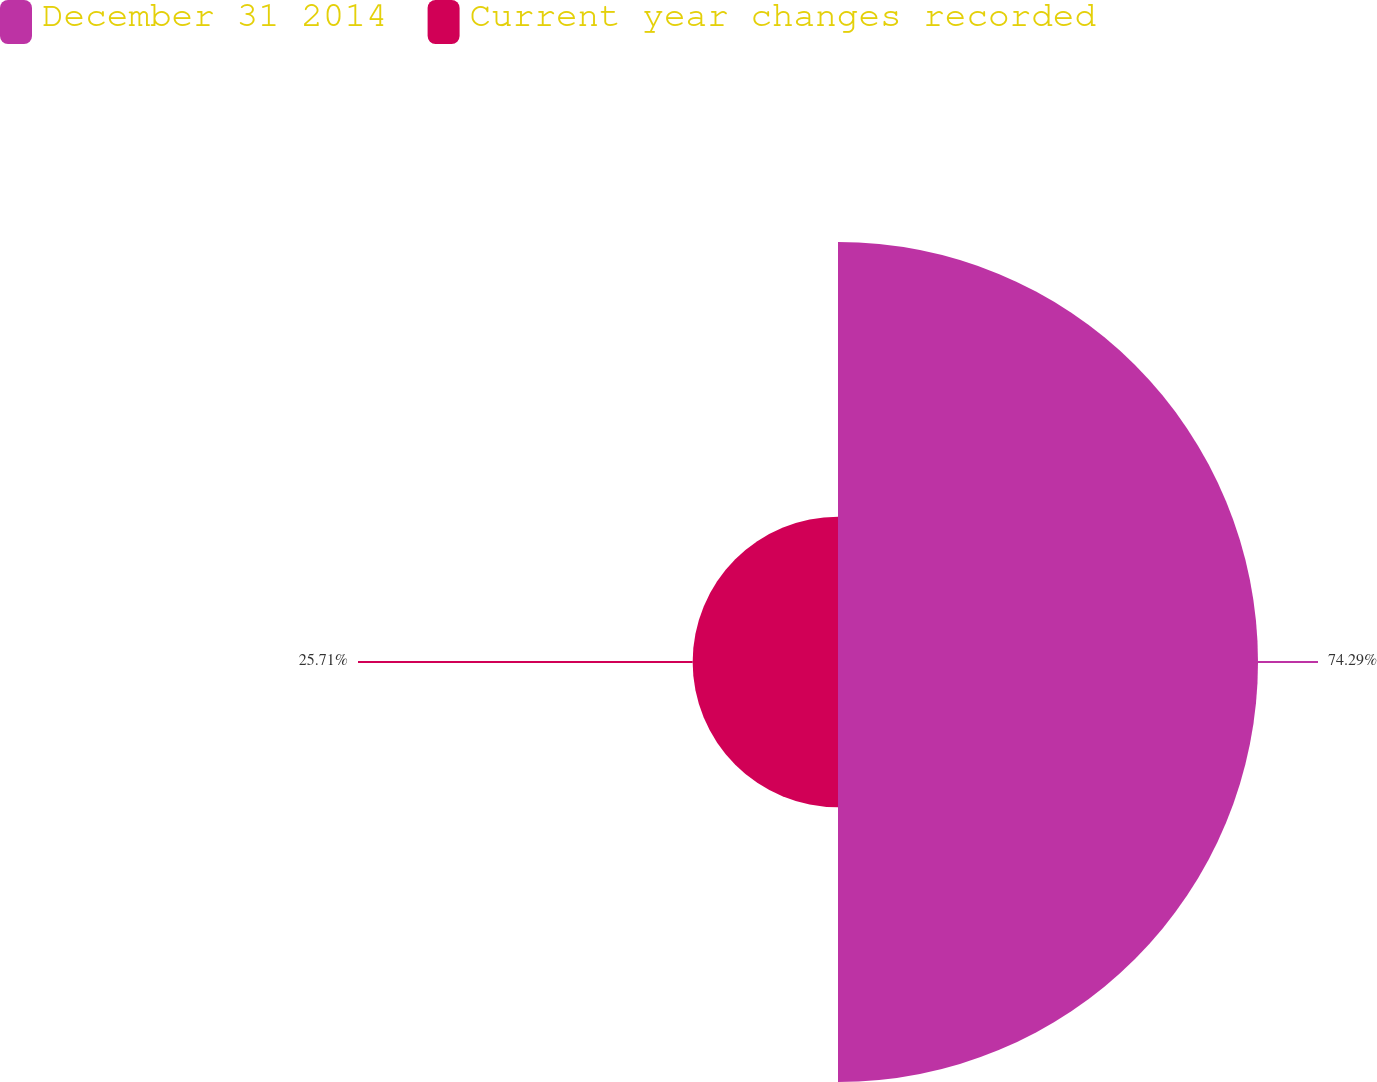Convert chart. <chart><loc_0><loc_0><loc_500><loc_500><pie_chart><fcel>December 31 2014<fcel>Current year changes recorded<nl><fcel>74.29%<fcel>25.71%<nl></chart> 